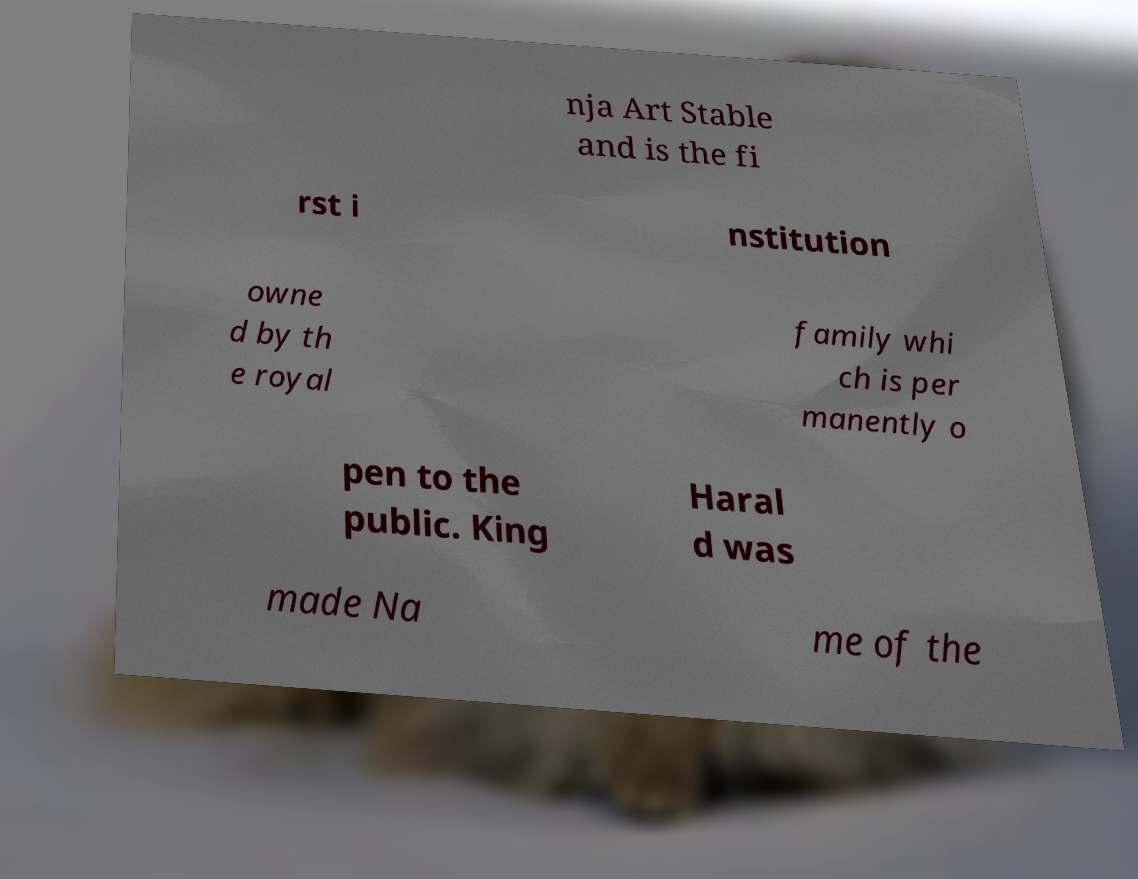Please identify and transcribe the text found in this image. nja Art Stable and is the fi rst i nstitution owne d by th e royal family whi ch is per manently o pen to the public. King Haral d was made Na me of the 